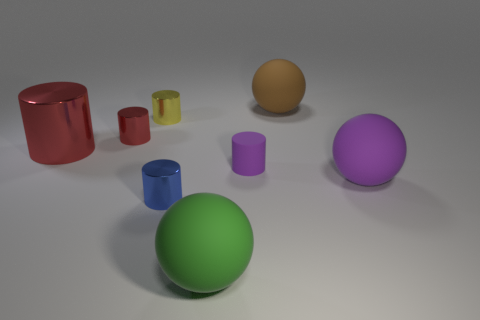Is the size of the blue shiny cylinder the same as the yellow cylinder?
Provide a succinct answer. Yes. What material is the yellow object?
Offer a very short reply. Metal. What is the color of the large object that is made of the same material as the small blue thing?
Offer a terse response. Red. Is the material of the small blue thing the same as the red thing that is behind the big red thing?
Offer a very short reply. Yes. What number of tiny red objects are the same material as the small blue object?
Give a very brief answer. 1. There is a tiny metallic thing that is in front of the tiny matte thing; what shape is it?
Your response must be concise. Cylinder. Is the material of the big purple sphere that is to the right of the blue cylinder the same as the big sphere that is behind the tiny matte object?
Ensure brevity in your answer.  Yes. Are there any tiny blue things that have the same shape as the large brown object?
Keep it short and to the point. No. How many objects are either matte balls that are left of the brown rubber ball or brown rubber cubes?
Provide a succinct answer. 1. Are there more large matte objects that are in front of the small blue thing than yellow metallic cylinders that are behind the yellow metallic cylinder?
Your answer should be compact. Yes. 